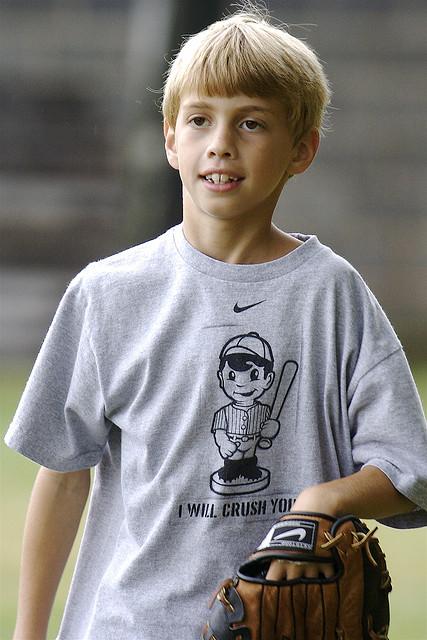What brand shirt is the kid wearing?
Answer briefly. Nike. What is the little boy on his shirt holding?
Answer briefly. Bat. What color is the boy's shirt?
Quick response, please. Gray. What is on the boys hand?
Write a very short answer. Glove. 